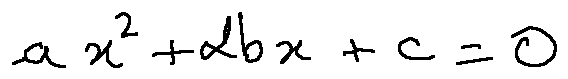<formula> <loc_0><loc_0><loc_500><loc_500>a x ^ { 2 } + 2 b x + c = 0</formula> 